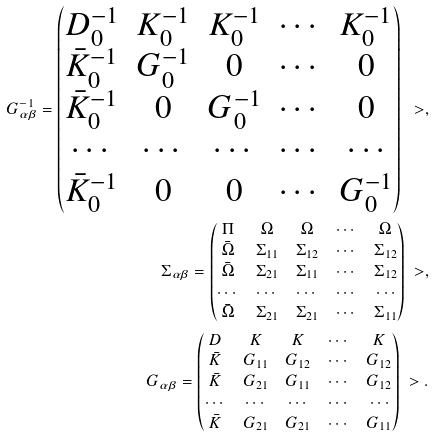<formula> <loc_0><loc_0><loc_500><loc_500>G _ { \alpha \beta } ^ { - 1 } = \begin{pmatrix} D _ { 0 } ^ { - 1 } & K _ { 0 } ^ { - 1 } & K _ { 0 } ^ { - 1 } & \cdots & K _ { 0 } ^ { - 1 } \\ \bar { K } _ { 0 } ^ { - 1 } & G _ { 0 } ^ { - 1 } & 0 & \cdots & 0 \\ \bar { K } _ { 0 } ^ { - 1 } & 0 & G _ { 0 } ^ { - 1 } & \cdots & 0 \\ \cdots & \cdots & \cdots & \cdots & \cdots \\ \bar { K } _ { 0 } ^ { - 1 } & 0 & 0 & \cdots & G _ { 0 } ^ { - 1 } \end{pmatrix} \ > , \\ \Sigma _ { \alpha \beta } = \begin{pmatrix} \Pi & \Omega & \Omega & \cdots & \Omega \\ \bar { \Omega } & \Sigma _ { 1 1 } & \Sigma _ { 1 2 } & \cdots & \Sigma _ { 1 2 } \\ \bar { \Omega } & \Sigma _ { 2 1 } & \Sigma _ { 1 1 } & \cdots & \Sigma _ { 1 2 } \\ \cdots & \cdots & \cdots & \cdots & \cdots \\ \bar { \Omega } & \Sigma _ { 2 1 } & \Sigma _ { 2 1 } & \cdots & \Sigma _ { 1 1 } \end{pmatrix} \ > , \\ G _ { \alpha \beta } = \begin{pmatrix} D & K & K & \cdots & K \\ \bar { K } & G _ { 1 1 } & G _ { 1 2 } & \cdots & G _ { 1 2 } \\ \bar { K } & G _ { 2 1 } & G _ { 1 1 } & \cdots & G _ { 1 2 } \\ \cdots & \cdots & \cdots & \cdots & \cdots \\ \bar { K } & G _ { 2 1 } & G _ { 2 1 } & \cdots & G _ { 1 1 } \end{pmatrix} \ > .</formula> 